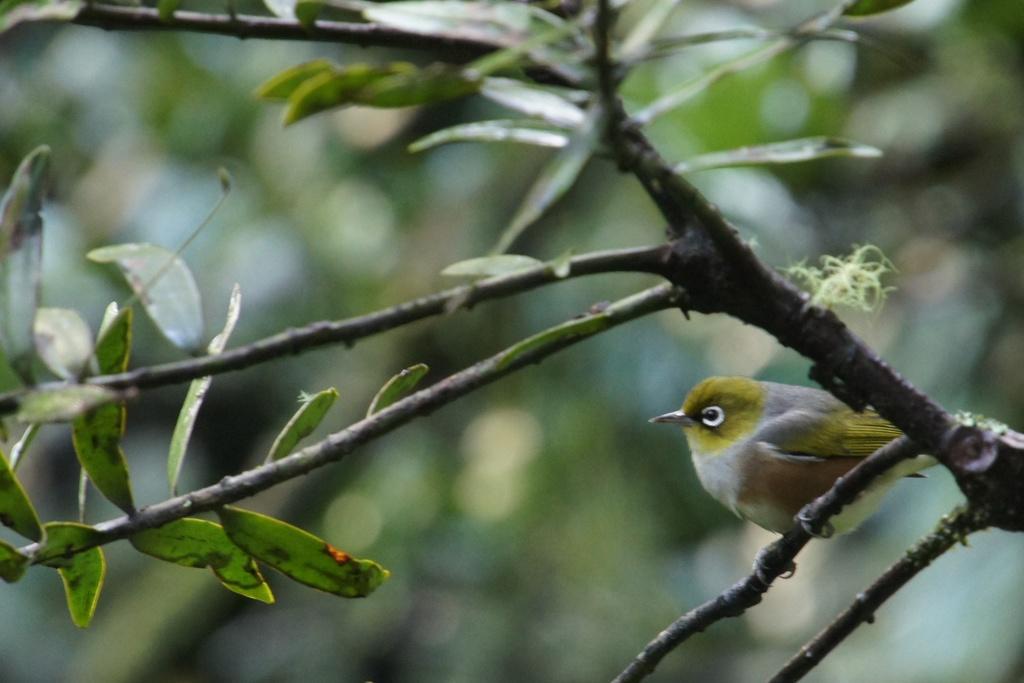Can you describe this image briefly? In this image we can see a bird. A bird is sitting on a branch of a plant. 